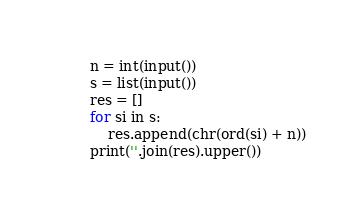<code> <loc_0><loc_0><loc_500><loc_500><_Python_>n = int(input())
s = list(input())
res = []
for si in s:
    res.append(chr(ord(si) + n))
print(''.join(res).upper())
</code> 